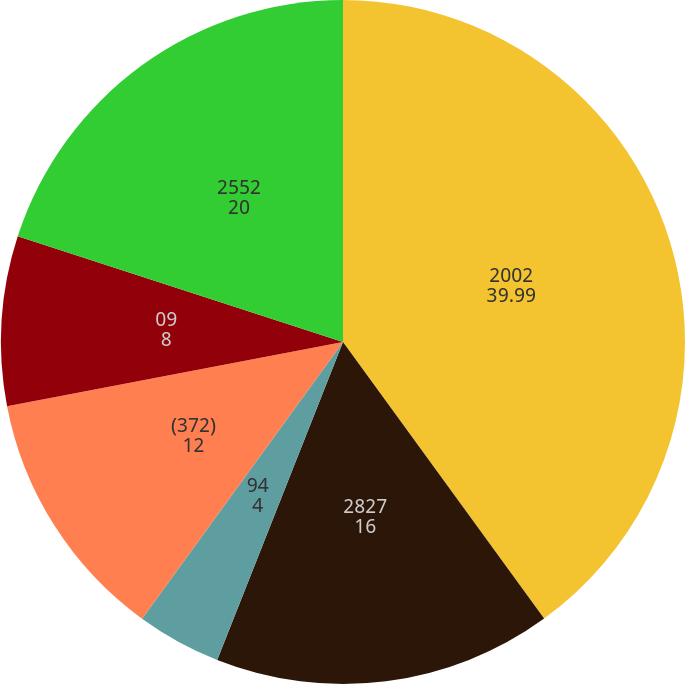Convert chart. <chart><loc_0><loc_0><loc_500><loc_500><pie_chart><fcel>2002<fcel>2827<fcel>94<fcel>(06)<fcel>(372)<fcel>09<fcel>2552<nl><fcel>39.99%<fcel>16.0%<fcel>4.0%<fcel>0.0%<fcel>12.0%<fcel>8.0%<fcel>20.0%<nl></chart> 